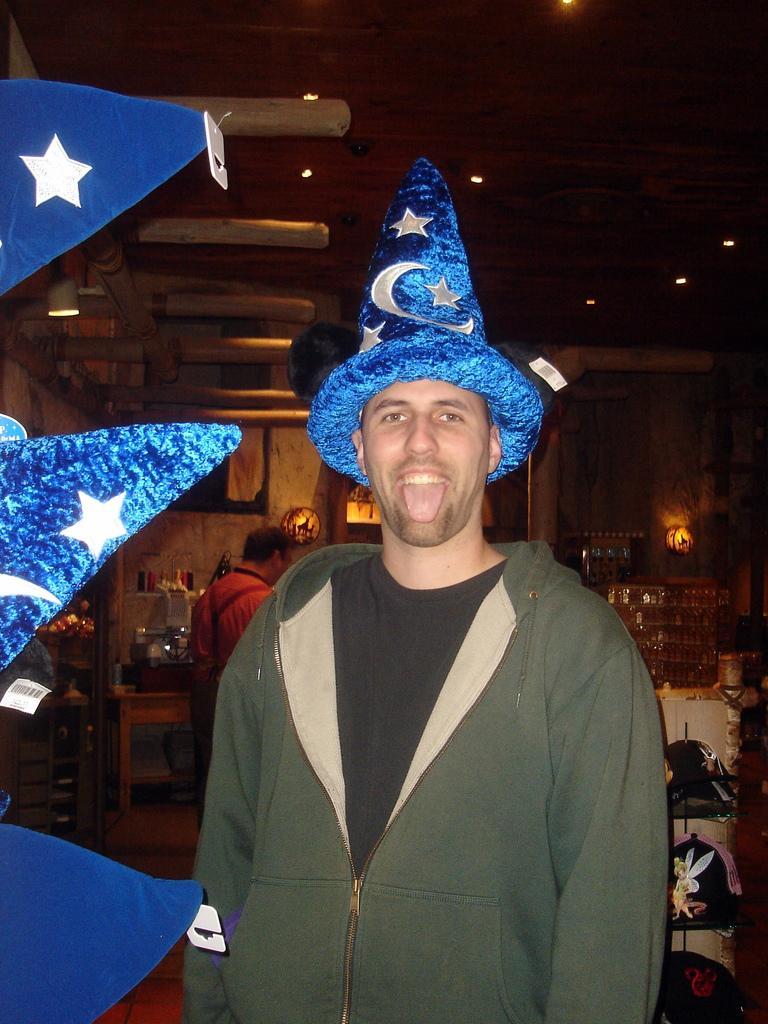How would you summarize this image in a sentence or two? In this picture I can see a man standing, he is wearing a cap on his head and another man standing in the back. I can see few lights to the ceiling and few items on the table. 